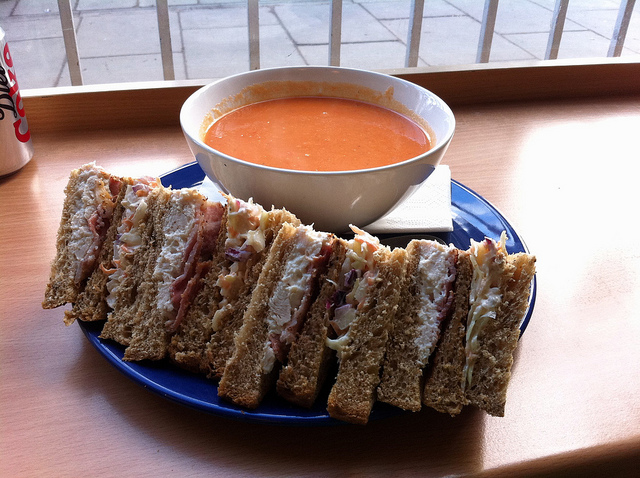Is the soup in the image homemade or canned? It's difficult to determine with absolute certainty from the image alone, but based on the smooth texture and consistent color, it's possible that the tomato soup could be either homemade or from a high-quality canned variety. 